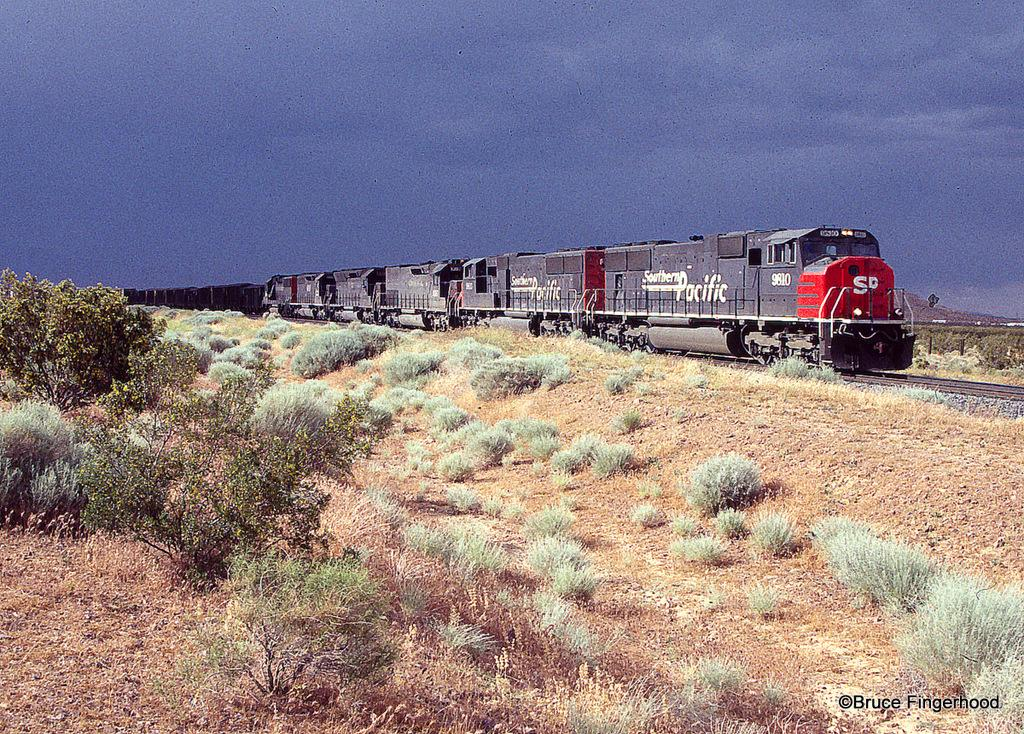What type of vegetation is on the left side of the image? There are trees on the left side of the image. What is the main subject in the middle of the image? A train is moving in the middle of the image. What is the color of the train? The train is black in color. On what surface is the train moving? The train is on a railway track. What is the condition of the sky in the image? The sky is cloudy in the image. Can you see any snow on the ground in the image? There is no snow visible in the image; the sky is cloudy, but no snow is mentioned or depicted. How many people are jumping off the train in the image? There are no people jumping off the train in the image; the train is moving on a railway track, but no people are visible. 